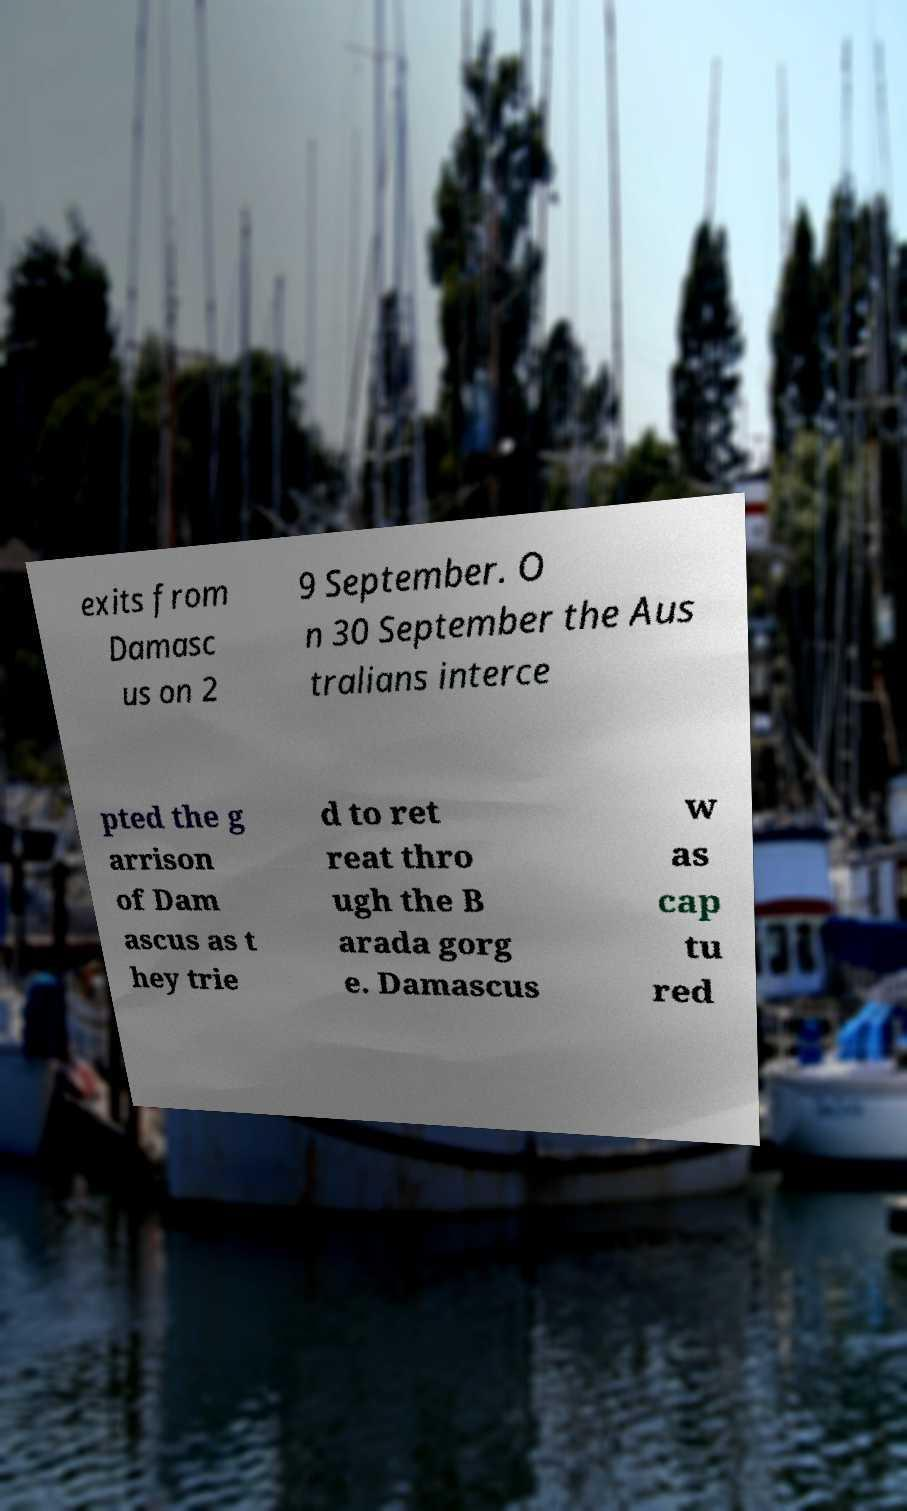Please identify and transcribe the text found in this image. exits from Damasc us on 2 9 September. O n 30 September the Aus tralians interce pted the g arrison of Dam ascus as t hey trie d to ret reat thro ugh the B arada gorg e. Damascus w as cap tu red 